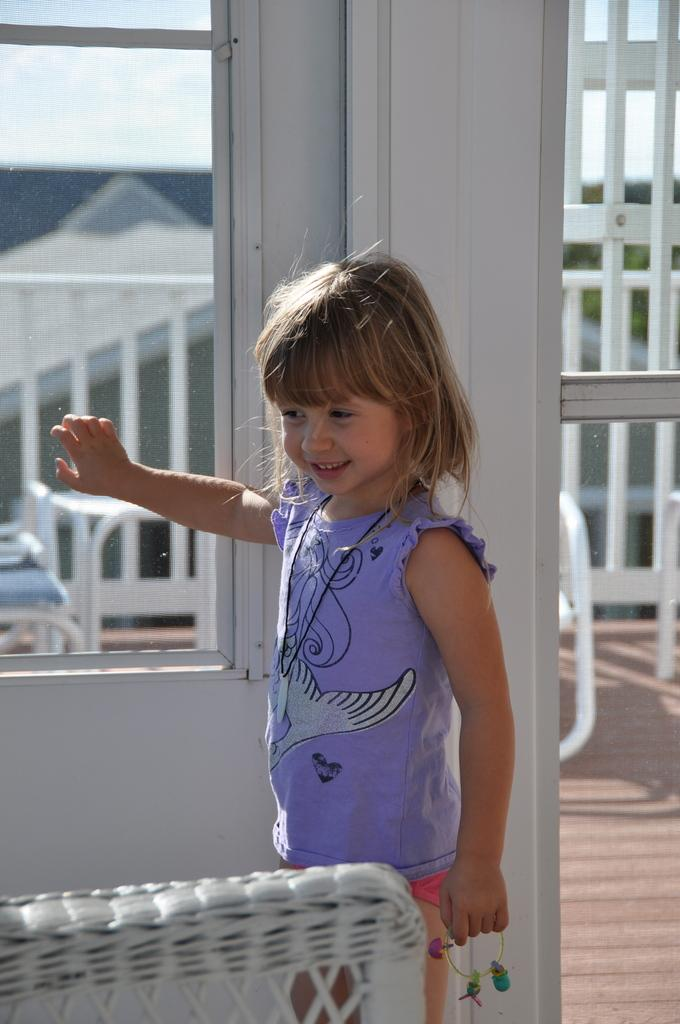What is the kid in the image doing? The kid is standing and smiling in the image. What can be seen in the background of the image? There are chairs, a table, iron grills, a house, and the sky visible in the background of the image. Can you describe the setting of the image? The image appears to be taken in a residential area, with a house and outdoor furniture visible in the background. What type of stem can be seen growing from the kid's head in the image? There is no stem growing from the kid's head in the image; the kid is simply standing and smiling. 